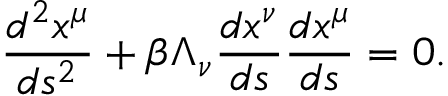<formula> <loc_0><loc_0><loc_500><loc_500>\frac { d ^ { 2 } x ^ { \mu } } { d s ^ { 2 } } + \beta \Lambda _ { \nu } \frac { d x ^ { \nu } } { d s } \frac { d x ^ { \mu } } { d s } = 0 .</formula> 